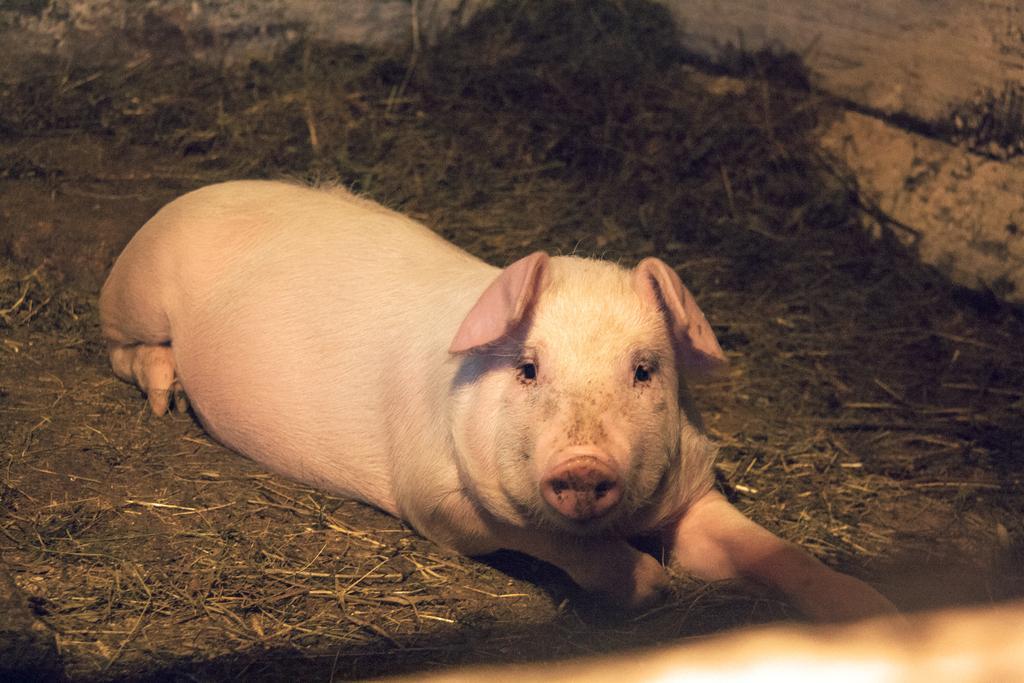Could you give a brief overview of what you see in this image? In this image I can see a pig is laying on the ground. In the background there is grass and a wall. 